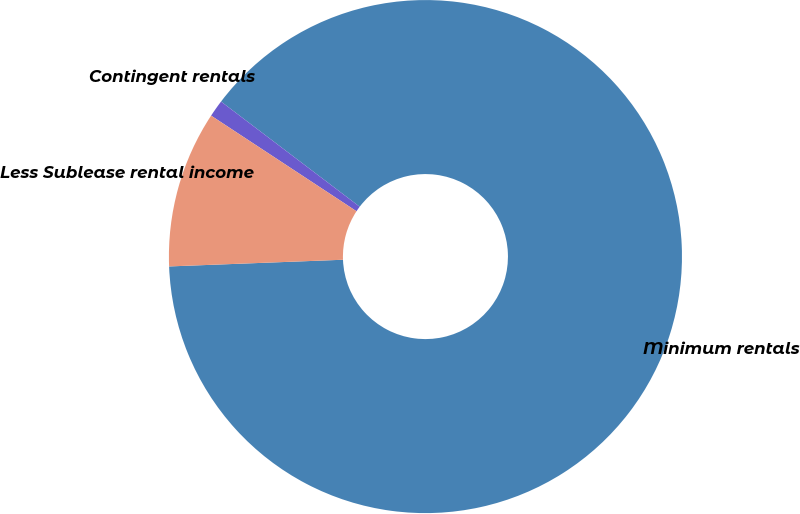Convert chart to OTSL. <chart><loc_0><loc_0><loc_500><loc_500><pie_chart><fcel>Minimum rentals<fcel>Contingent rentals<fcel>Less Sublease rental income<nl><fcel>89.07%<fcel>1.07%<fcel>9.87%<nl></chart> 